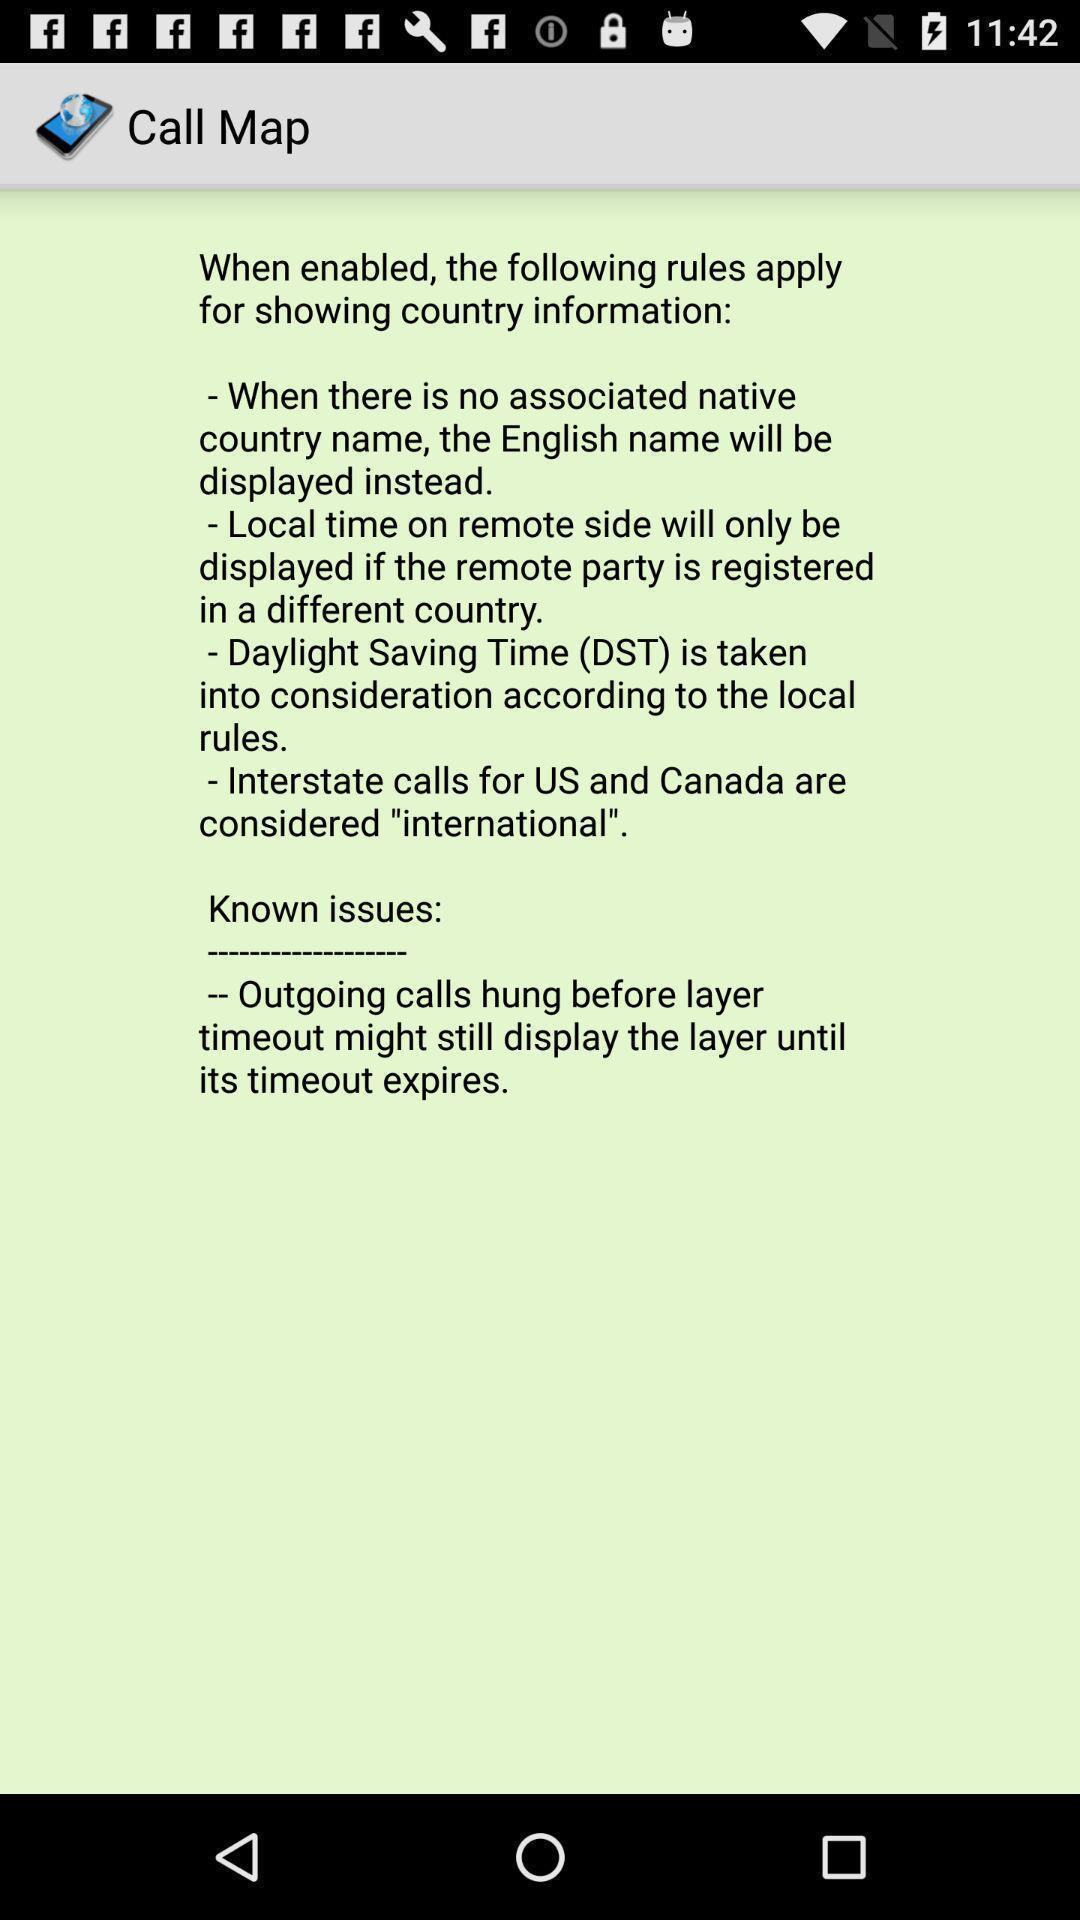Describe the visual elements of this screenshot. Page displaying the instructions. 